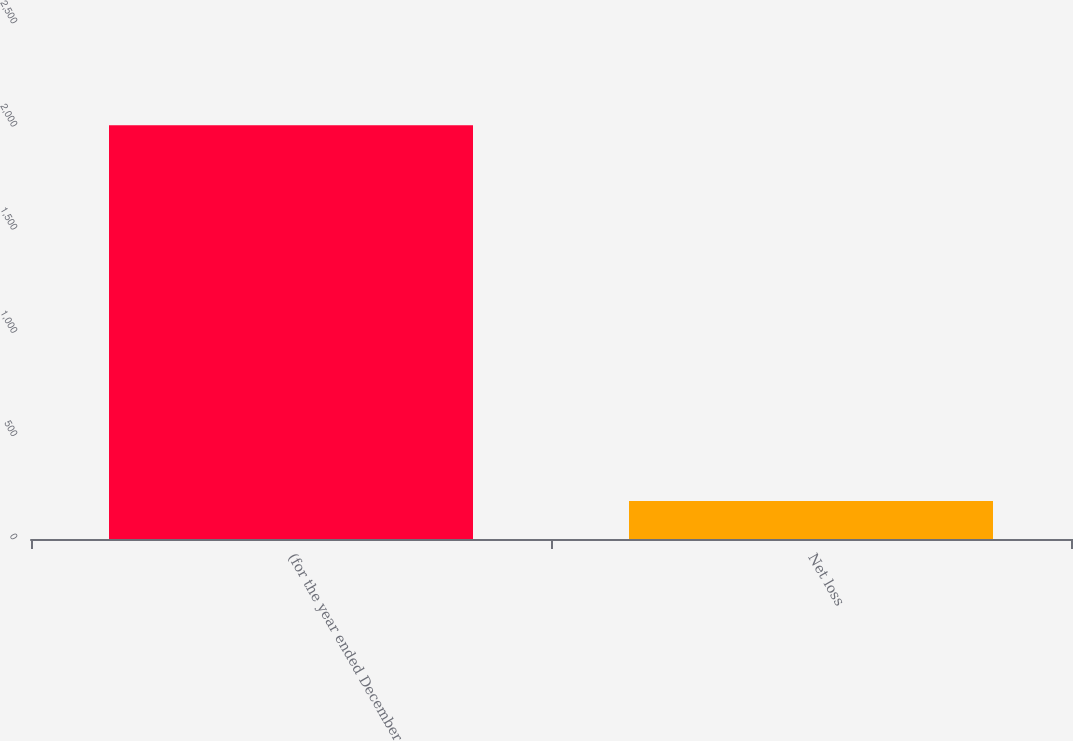<chart> <loc_0><loc_0><loc_500><loc_500><bar_chart><fcel>(for the year ended December<fcel>Net loss<nl><fcel>2005<fcel>184<nl></chart> 